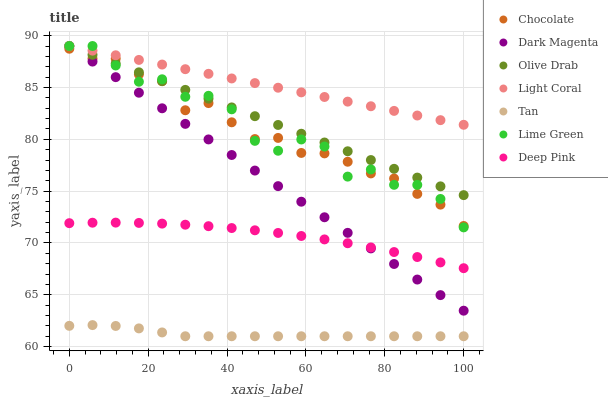Does Tan have the minimum area under the curve?
Answer yes or no. Yes. Does Light Coral have the maximum area under the curve?
Answer yes or no. Yes. Does Dark Magenta have the minimum area under the curve?
Answer yes or no. No. Does Dark Magenta have the maximum area under the curve?
Answer yes or no. No. Is Dark Magenta the smoothest?
Answer yes or no. Yes. Is Lime Green the roughest?
Answer yes or no. Yes. Is Chocolate the smoothest?
Answer yes or no. No. Is Chocolate the roughest?
Answer yes or no. No. Does Tan have the lowest value?
Answer yes or no. Yes. Does Dark Magenta have the lowest value?
Answer yes or no. No. Does Olive Drab have the highest value?
Answer yes or no. Yes. Does Chocolate have the highest value?
Answer yes or no. No. Is Deep Pink less than Chocolate?
Answer yes or no. Yes. Is Chocolate greater than Tan?
Answer yes or no. Yes. Does Deep Pink intersect Dark Magenta?
Answer yes or no. Yes. Is Deep Pink less than Dark Magenta?
Answer yes or no. No. Is Deep Pink greater than Dark Magenta?
Answer yes or no. No. Does Deep Pink intersect Chocolate?
Answer yes or no. No. 